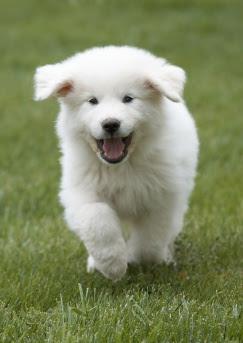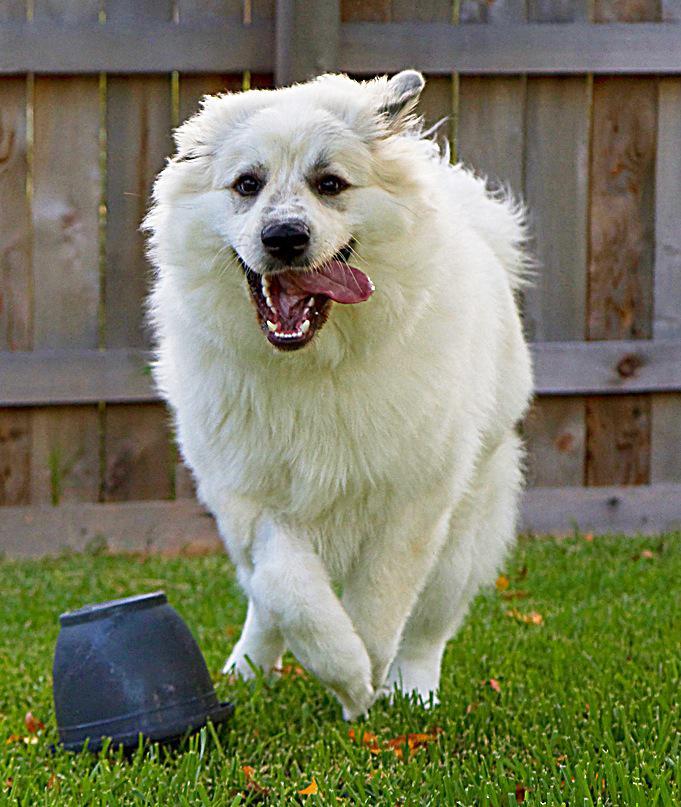The first image is the image on the left, the second image is the image on the right. Examine the images to the left and right. Is the description "The dog in the image on the left is running through the grass." accurate? Answer yes or no. Yes. The first image is the image on the left, the second image is the image on the right. Analyze the images presented: Is the assertion "An image shows a dog running across the grass with its tongue sticking out and to one side." valid? Answer yes or no. Yes. 